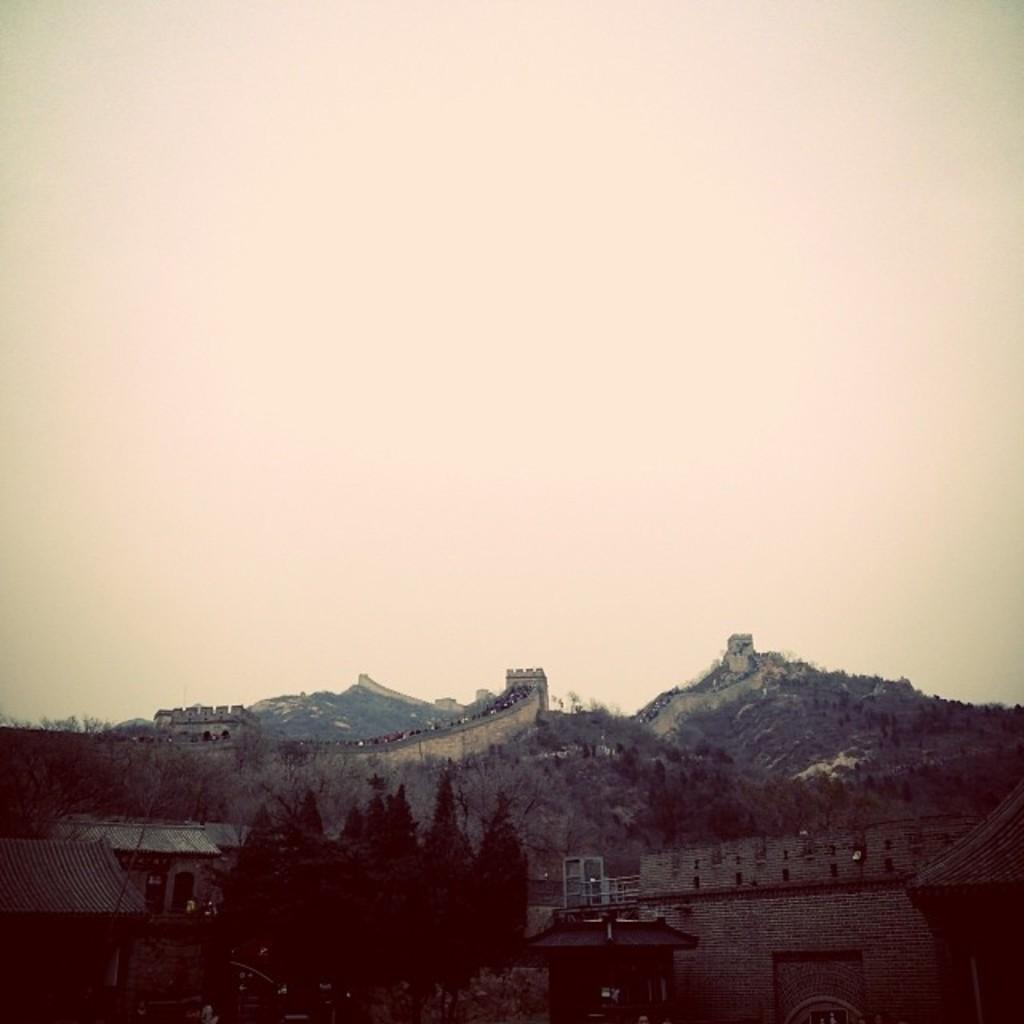Could you give a brief overview of what you see in this image? In this picture we can see sheds, here we can see trees, some objects and in the background we can see mountains, sky. 